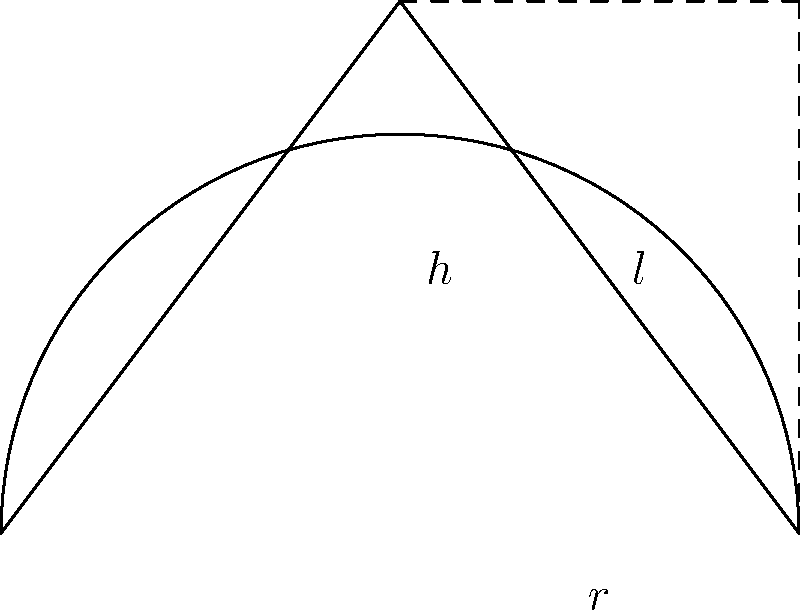You're designing a new conical pastry bag for your bakery. The bag has a slant height of 15 cm and a base radius of 6 cm. Calculate the surface area of the pastry bag, excluding the circular base. Round your answer to the nearest square centimeter. To calculate the surface area of a conical pastry bag (excluding the base), we need to use the formula for the lateral surface area of a cone:

$$A = \pi r l$$

Where:
$A$ = lateral surface area
$r$ = radius of the base
$l$ = slant height of the cone

Given:
$r = 6$ cm
$l = 15$ cm

Let's solve step by step:

1) Substitute the values into the formula:
   $$A = \pi \cdot 6 \cdot 15$$

2) Simplify:
   $$A = 90\pi$$

3) Calculate (use $\pi \approx 3.14159$):
   $$A \approx 90 \cdot 3.14159 = 282.74331$$

4) Round to the nearest square centimeter:
   $$A \approx 283 \text{ cm}^2$$

Therefore, the surface area of the conical pastry bag, excluding the base, is approximately 283 square centimeters.
Answer: 283 cm² 